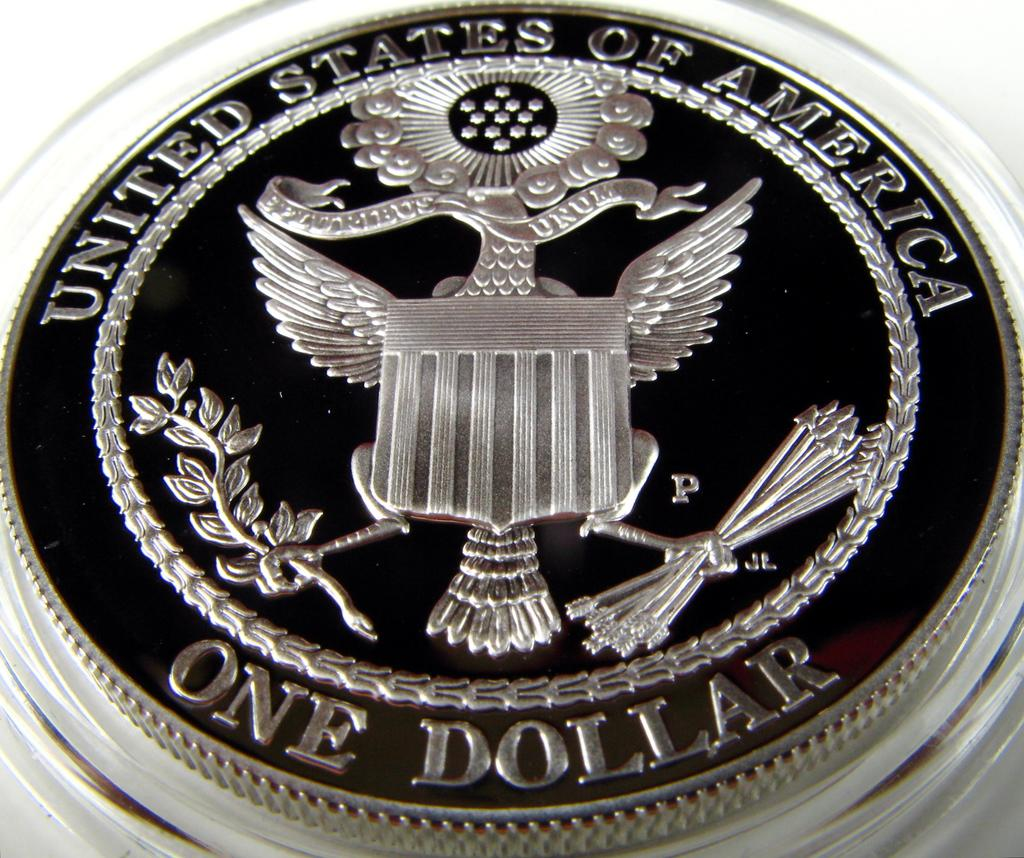<image>
Present a compact description of the photo's key features. A United States One Dollar coin includes a eagle holding objects in its feet. 